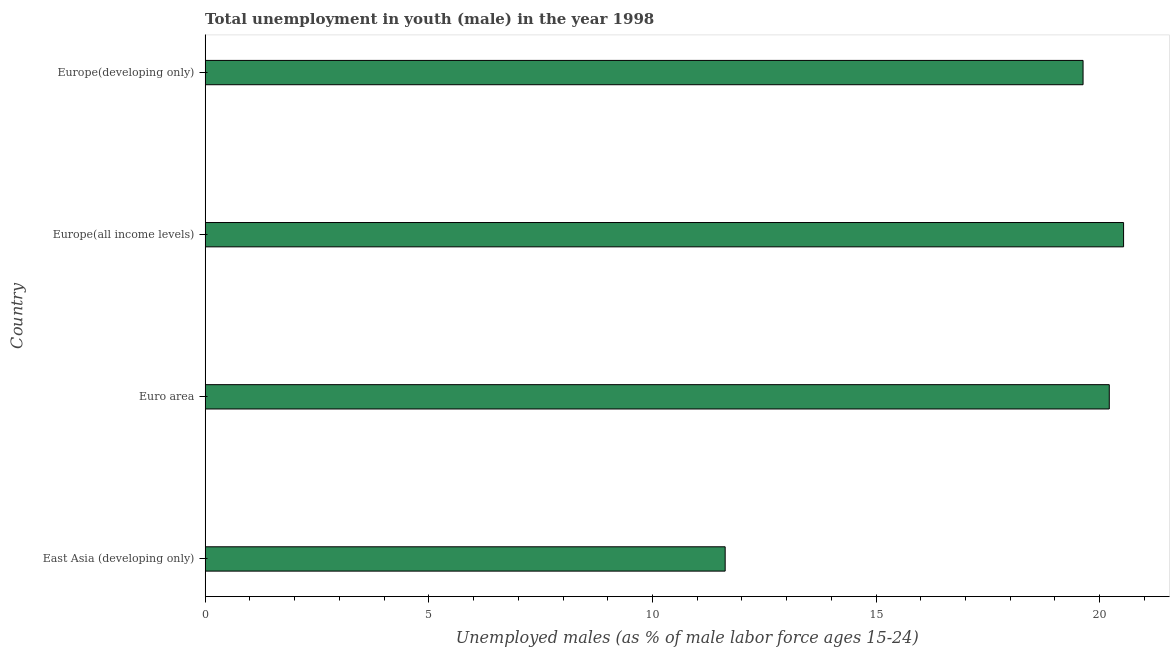Does the graph contain any zero values?
Offer a terse response. No. What is the title of the graph?
Your answer should be compact. Total unemployment in youth (male) in the year 1998. What is the label or title of the X-axis?
Offer a very short reply. Unemployed males (as % of male labor force ages 15-24). What is the label or title of the Y-axis?
Offer a very short reply. Country. What is the unemployed male youth population in Euro area?
Ensure brevity in your answer.  20.21. Across all countries, what is the maximum unemployed male youth population?
Offer a terse response. 20.53. Across all countries, what is the minimum unemployed male youth population?
Give a very brief answer. 11.63. In which country was the unemployed male youth population maximum?
Keep it short and to the point. Europe(all income levels). In which country was the unemployed male youth population minimum?
Make the answer very short. East Asia (developing only). What is the sum of the unemployed male youth population?
Make the answer very short. 72. What is the difference between the unemployed male youth population in East Asia (developing only) and Europe(developing only)?
Your answer should be compact. -8. What is the average unemployed male youth population per country?
Make the answer very short. 18. What is the median unemployed male youth population?
Keep it short and to the point. 19.92. In how many countries, is the unemployed male youth population greater than 20 %?
Provide a short and direct response. 2. What is the ratio of the unemployed male youth population in East Asia (developing only) to that in Europe(developing only)?
Offer a very short reply. 0.59. Is the difference between the unemployed male youth population in Euro area and Europe(developing only) greater than the difference between any two countries?
Offer a terse response. No. What is the difference between the highest and the second highest unemployed male youth population?
Provide a short and direct response. 0.32. Is the sum of the unemployed male youth population in Euro area and Europe(developing only) greater than the maximum unemployed male youth population across all countries?
Make the answer very short. Yes. What is the difference between the highest and the lowest unemployed male youth population?
Offer a very short reply. 8.91. How many countries are there in the graph?
Your answer should be very brief. 4. Are the values on the major ticks of X-axis written in scientific E-notation?
Ensure brevity in your answer.  No. What is the Unemployed males (as % of male labor force ages 15-24) of East Asia (developing only)?
Ensure brevity in your answer.  11.63. What is the Unemployed males (as % of male labor force ages 15-24) of Euro area?
Provide a succinct answer. 20.21. What is the Unemployed males (as % of male labor force ages 15-24) in Europe(all income levels)?
Keep it short and to the point. 20.53. What is the Unemployed males (as % of male labor force ages 15-24) of Europe(developing only)?
Give a very brief answer. 19.63. What is the difference between the Unemployed males (as % of male labor force ages 15-24) in East Asia (developing only) and Euro area?
Make the answer very short. -8.59. What is the difference between the Unemployed males (as % of male labor force ages 15-24) in East Asia (developing only) and Europe(all income levels)?
Offer a very short reply. -8.91. What is the difference between the Unemployed males (as % of male labor force ages 15-24) in East Asia (developing only) and Europe(developing only)?
Provide a succinct answer. -8. What is the difference between the Unemployed males (as % of male labor force ages 15-24) in Euro area and Europe(all income levels)?
Provide a short and direct response. -0.32. What is the difference between the Unemployed males (as % of male labor force ages 15-24) in Euro area and Europe(developing only)?
Give a very brief answer. 0.59. What is the difference between the Unemployed males (as % of male labor force ages 15-24) in Europe(all income levels) and Europe(developing only)?
Keep it short and to the point. 0.91. What is the ratio of the Unemployed males (as % of male labor force ages 15-24) in East Asia (developing only) to that in Euro area?
Make the answer very short. 0.57. What is the ratio of the Unemployed males (as % of male labor force ages 15-24) in East Asia (developing only) to that in Europe(all income levels)?
Give a very brief answer. 0.57. What is the ratio of the Unemployed males (as % of male labor force ages 15-24) in East Asia (developing only) to that in Europe(developing only)?
Your response must be concise. 0.59. What is the ratio of the Unemployed males (as % of male labor force ages 15-24) in Euro area to that in Europe(all income levels)?
Ensure brevity in your answer.  0.98. What is the ratio of the Unemployed males (as % of male labor force ages 15-24) in Europe(all income levels) to that in Europe(developing only)?
Provide a short and direct response. 1.05. 